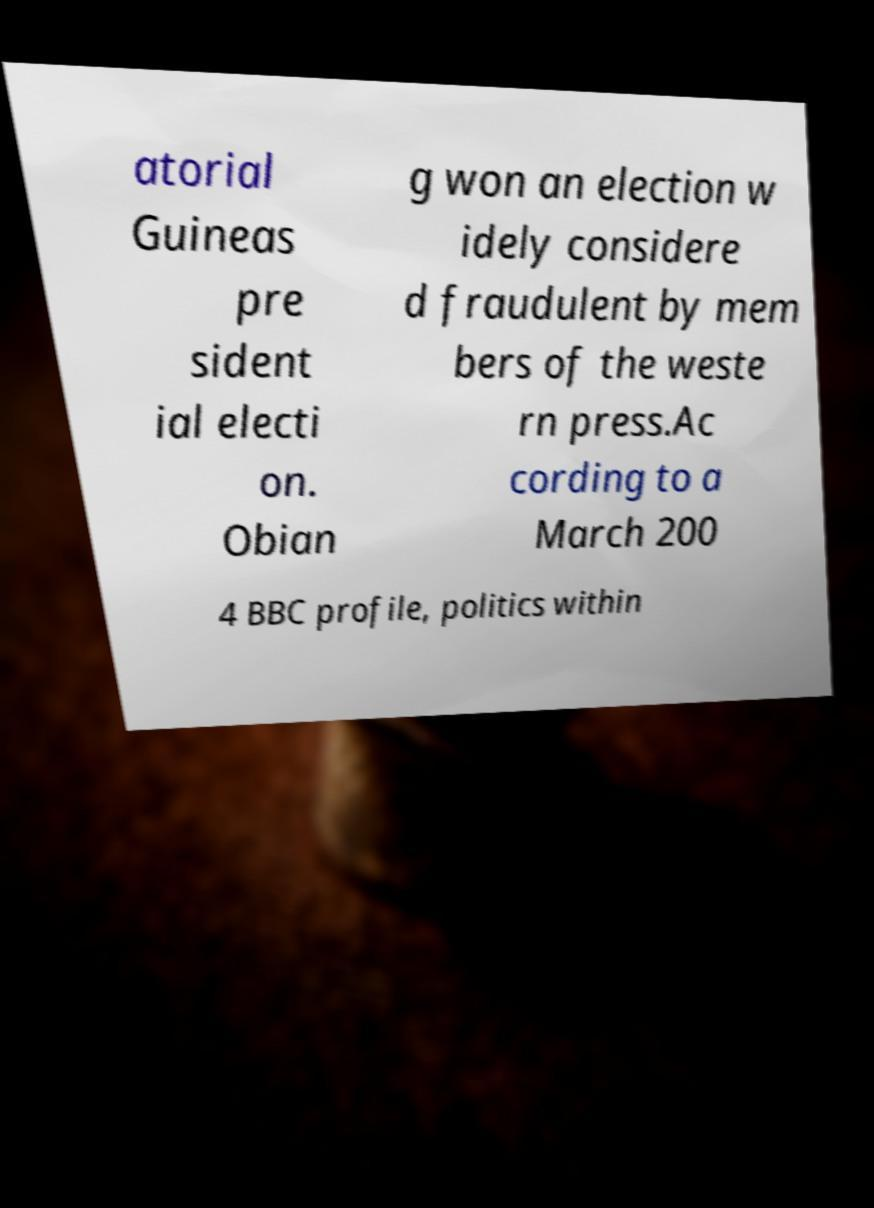For documentation purposes, I need the text within this image transcribed. Could you provide that? atorial Guineas pre sident ial electi on. Obian g won an election w idely considere d fraudulent by mem bers of the weste rn press.Ac cording to a March 200 4 BBC profile, politics within 